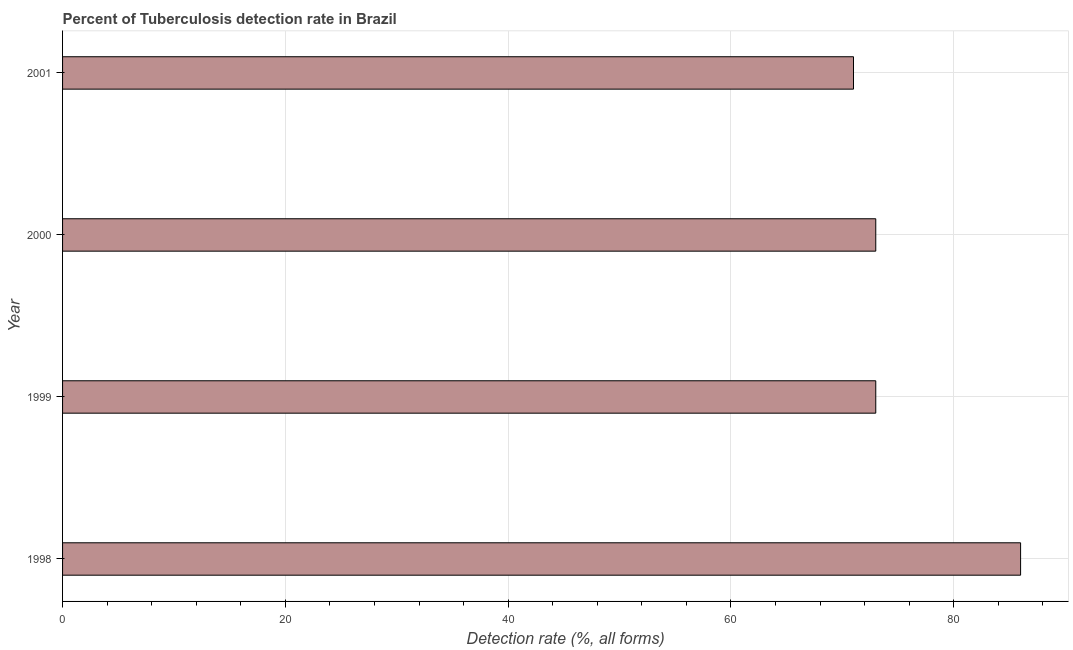Does the graph contain any zero values?
Your response must be concise. No. Does the graph contain grids?
Your answer should be compact. Yes. What is the title of the graph?
Offer a terse response. Percent of Tuberculosis detection rate in Brazil. What is the label or title of the X-axis?
Give a very brief answer. Detection rate (%, all forms). What is the detection rate of tuberculosis in 1999?
Offer a very short reply. 73. Across all years, what is the minimum detection rate of tuberculosis?
Keep it short and to the point. 71. In which year was the detection rate of tuberculosis maximum?
Provide a short and direct response. 1998. In which year was the detection rate of tuberculosis minimum?
Your response must be concise. 2001. What is the sum of the detection rate of tuberculosis?
Provide a succinct answer. 303. What is the median detection rate of tuberculosis?
Give a very brief answer. 73. Is the difference between the detection rate of tuberculosis in 1998 and 2001 greater than the difference between any two years?
Ensure brevity in your answer.  Yes. What is the difference between the highest and the second highest detection rate of tuberculosis?
Make the answer very short. 13. Is the sum of the detection rate of tuberculosis in 1998 and 1999 greater than the maximum detection rate of tuberculosis across all years?
Provide a succinct answer. Yes. What is the difference between the highest and the lowest detection rate of tuberculosis?
Give a very brief answer. 15. What is the Detection rate (%, all forms) in 1998?
Make the answer very short. 86. What is the Detection rate (%, all forms) of 2000?
Provide a succinct answer. 73. What is the Detection rate (%, all forms) of 2001?
Your answer should be very brief. 71. What is the difference between the Detection rate (%, all forms) in 1998 and 1999?
Offer a very short reply. 13. What is the difference between the Detection rate (%, all forms) in 1998 and 2001?
Provide a short and direct response. 15. What is the difference between the Detection rate (%, all forms) in 1999 and 2001?
Keep it short and to the point. 2. What is the difference between the Detection rate (%, all forms) in 2000 and 2001?
Provide a succinct answer. 2. What is the ratio of the Detection rate (%, all forms) in 1998 to that in 1999?
Provide a short and direct response. 1.18. What is the ratio of the Detection rate (%, all forms) in 1998 to that in 2000?
Give a very brief answer. 1.18. What is the ratio of the Detection rate (%, all forms) in 1998 to that in 2001?
Your answer should be very brief. 1.21. What is the ratio of the Detection rate (%, all forms) in 1999 to that in 2001?
Offer a terse response. 1.03. What is the ratio of the Detection rate (%, all forms) in 2000 to that in 2001?
Offer a terse response. 1.03. 